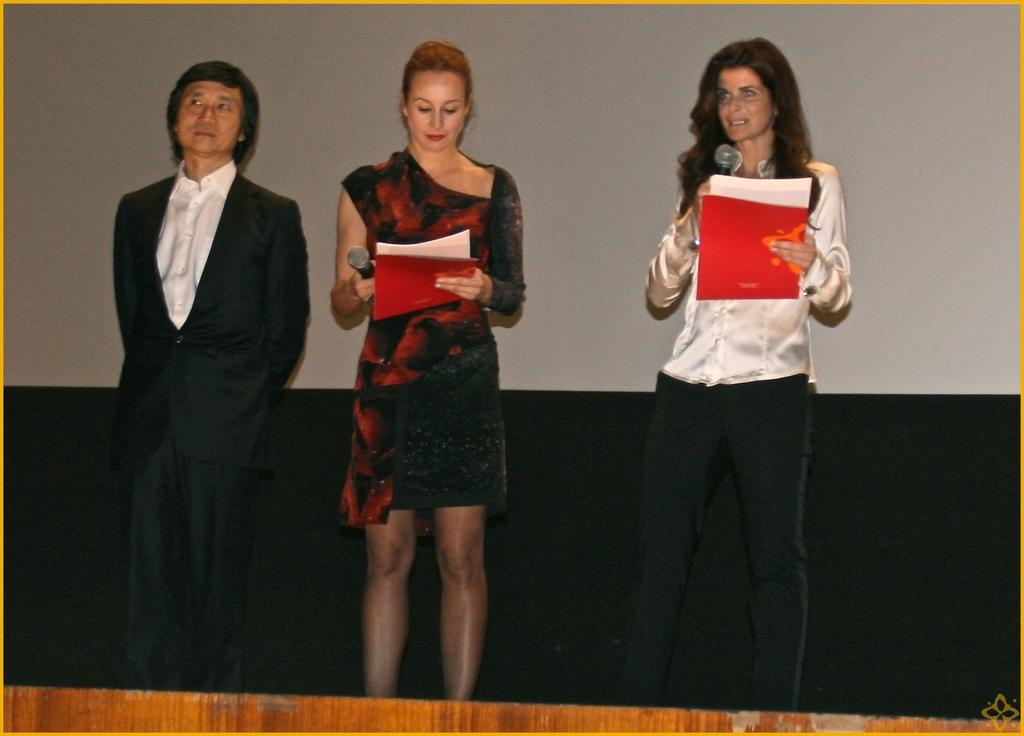How many people are in the image? There are two women and a man in the image. Where are they located in the image? They are standing on a stage. What are the women holding in the image? One of the women is holding a microphone, and the other woman is holding a microphone and papers. What can be seen in the background of the image? There is a wall in the background of the image. What color is the snail crawling on the wall in the image? There is no snail present in the image; it only features two women, a man, and a wall in the background. 